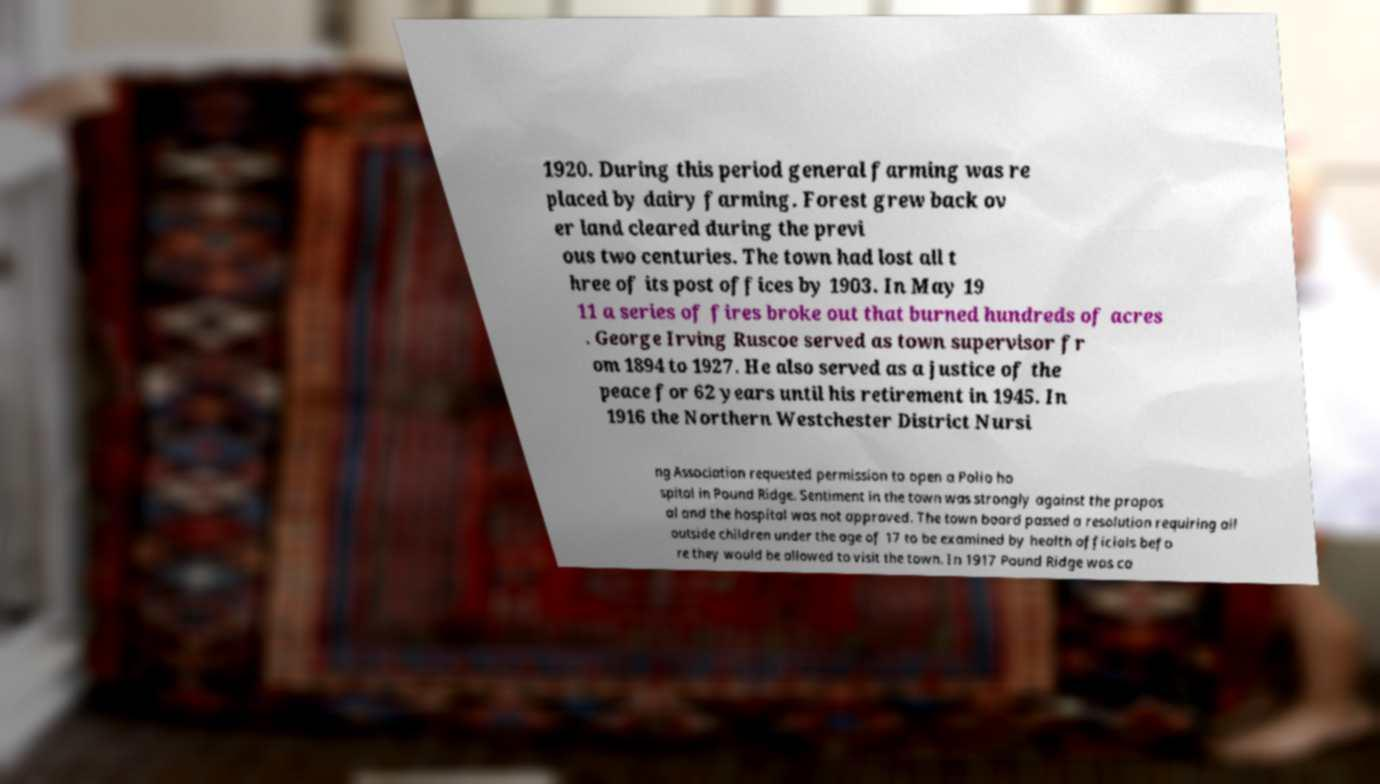For documentation purposes, I need the text within this image transcribed. Could you provide that? 1920. During this period general farming was re placed by dairy farming. Forest grew back ov er land cleared during the previ ous two centuries. The town had lost all t hree of its post offices by 1903. In May 19 11 a series of fires broke out that burned hundreds of acres . George Irving Ruscoe served as town supervisor fr om 1894 to 1927. He also served as a justice of the peace for 62 years until his retirement in 1945. In 1916 the Northern Westchester District Nursi ng Association requested permission to open a Polio ho spital in Pound Ridge. Sentiment in the town was strongly against the propos al and the hospital was not approved. The town board passed a resolution requiring all outside children under the age of 17 to be examined by health officials befo re they would be allowed to visit the town. In 1917 Pound Ridge was ca 